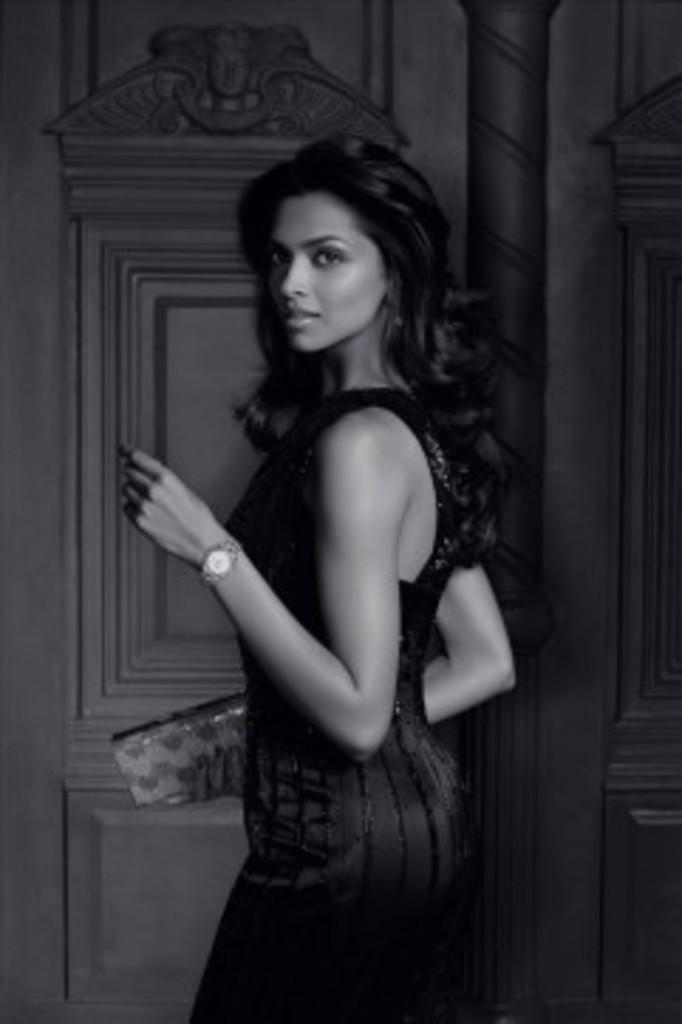In one or two sentences, can you explain what this image depicts? This picture is in black and white where we can see a woman wearing dress and watch is holding a wallet in her hand. In the background, I can see a pillar and the wall. 